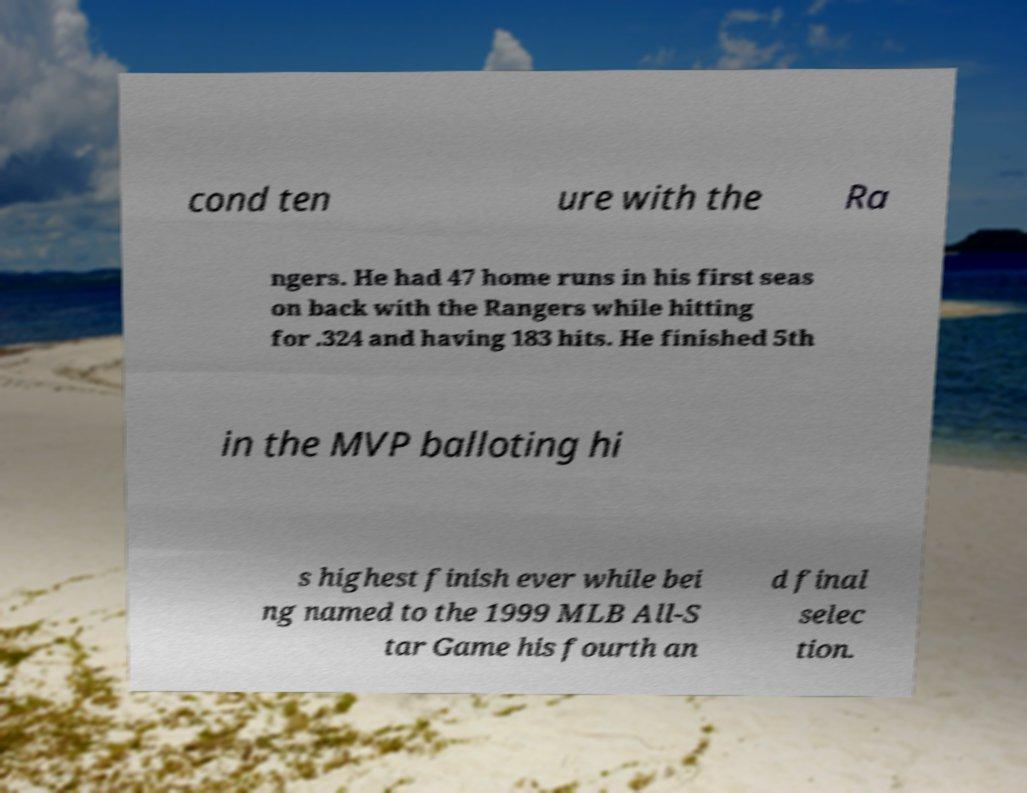I need the written content from this picture converted into text. Can you do that? cond ten ure with the Ra ngers. He had 47 home runs in his first seas on back with the Rangers while hitting for .324 and having 183 hits. He finished 5th in the MVP balloting hi s highest finish ever while bei ng named to the 1999 MLB All-S tar Game his fourth an d final selec tion. 